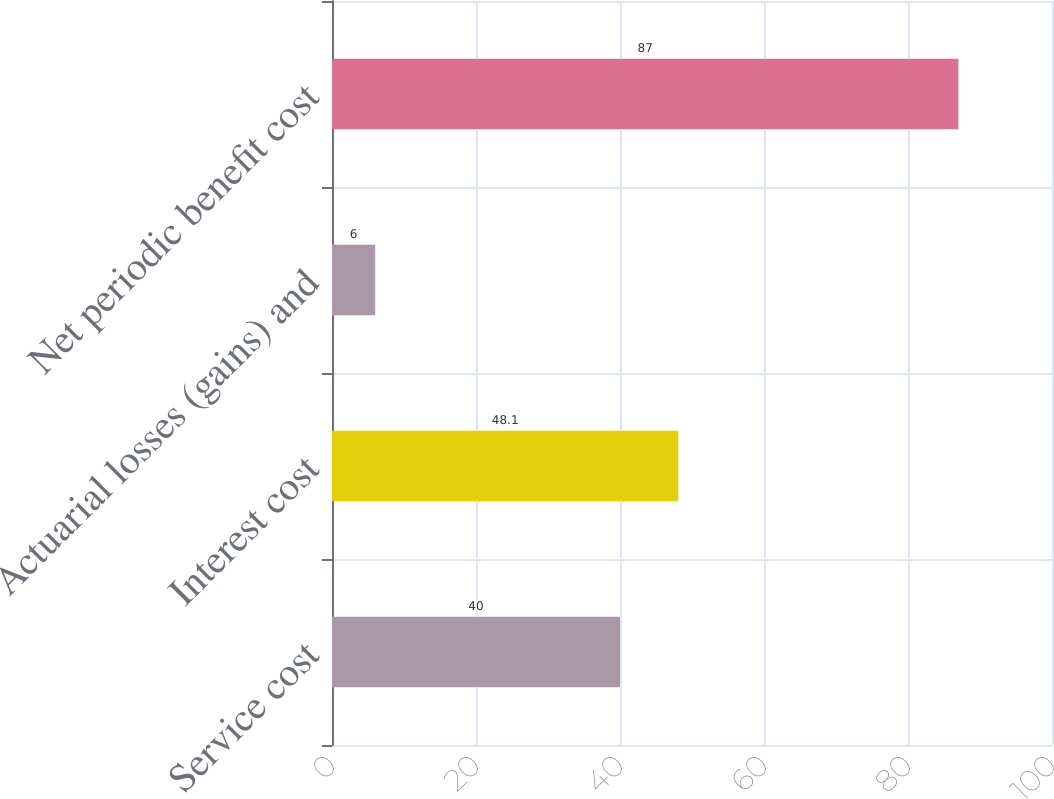<chart> <loc_0><loc_0><loc_500><loc_500><bar_chart><fcel>Service cost<fcel>Interest cost<fcel>Actuarial losses (gains) and<fcel>Net periodic benefit cost<nl><fcel>40<fcel>48.1<fcel>6<fcel>87<nl></chart> 